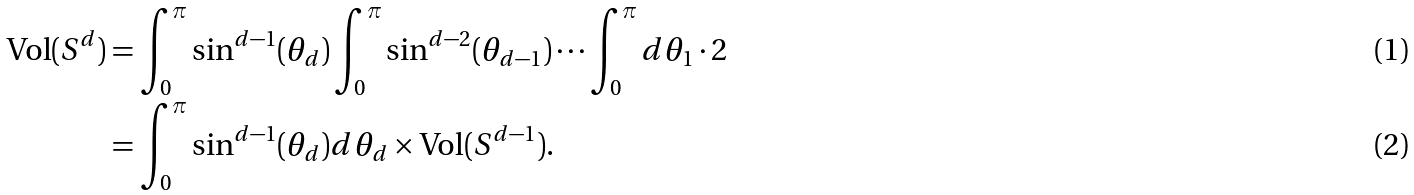<formula> <loc_0><loc_0><loc_500><loc_500>\text {Vol} ( S ^ { d } ) & = \int _ { 0 } ^ { \pi } \sin ^ { d - 1 } ( \theta _ { d } ) \int _ { 0 } ^ { \pi } \sin ^ { d - 2 } ( \theta _ { d - 1 } ) \cdots \int _ { 0 } ^ { \pi } d \theta _ { 1 } \cdot 2 \\ & = \int _ { 0 } ^ { \pi } \sin ^ { d - 1 } ( \theta _ { d } ) d \theta _ { d } \times \text {Vol} ( S ^ { d - 1 } ) .</formula> 